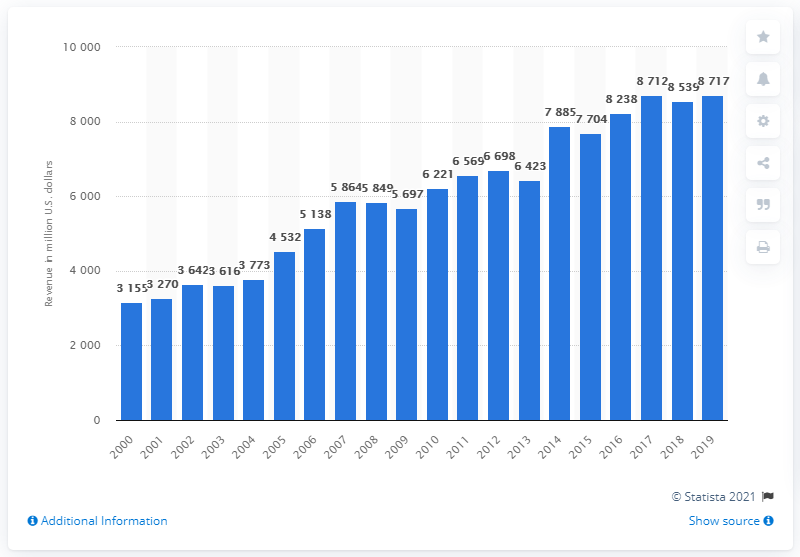Identify some key points in this picture. During the given period, the highest revenue recorded was 8,717. 